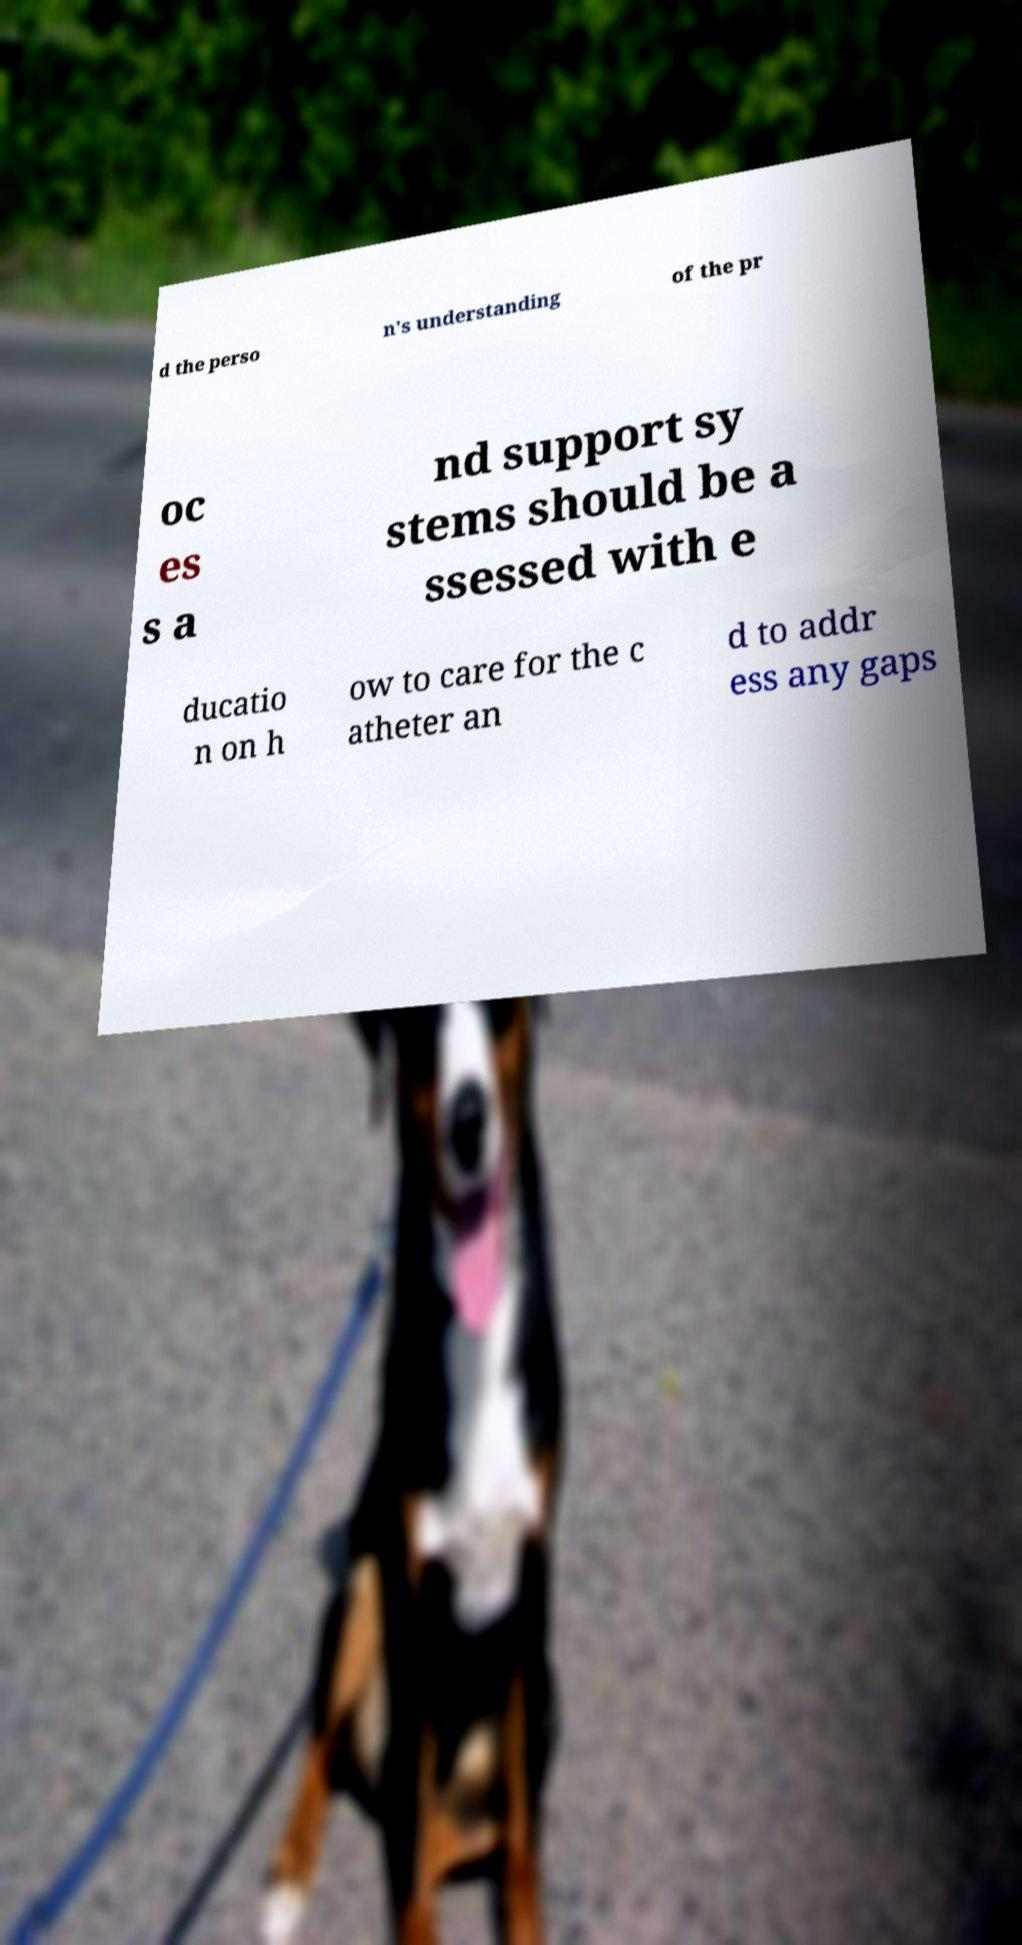There's text embedded in this image that I need extracted. Can you transcribe it verbatim? d the perso n's understanding of the pr oc es s a nd support sy stems should be a ssessed with e ducatio n on h ow to care for the c atheter an d to addr ess any gaps 